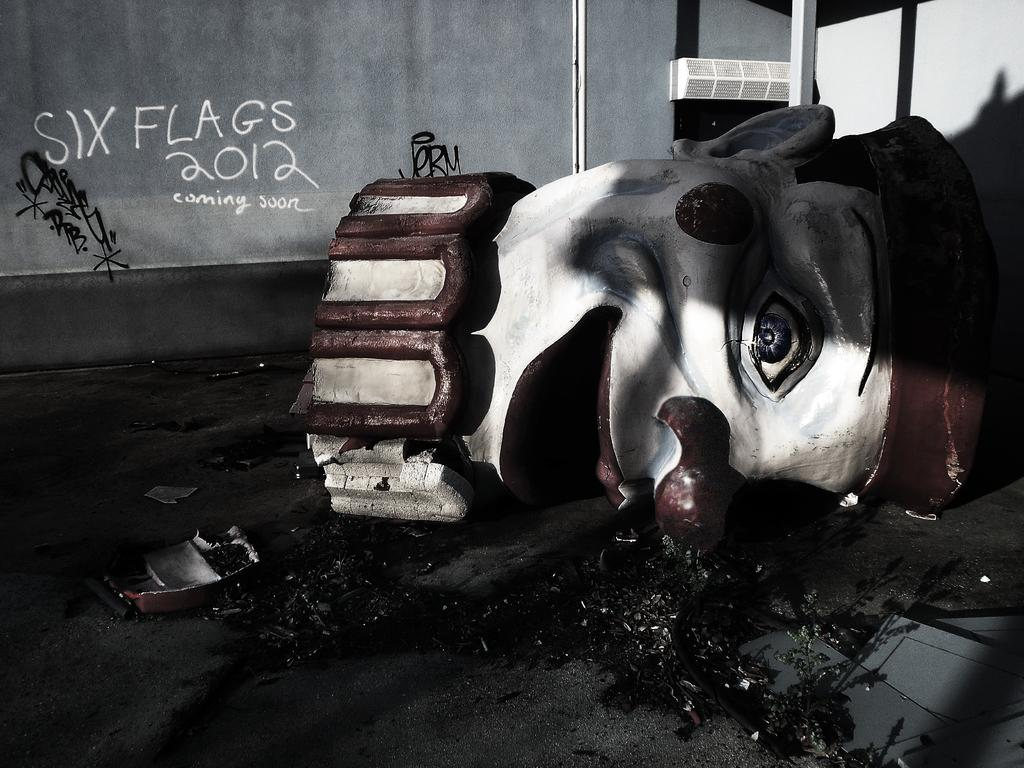What is the main subject in the middle of the image? There is a doll in the middle of the image. What can be seen on the left side of the image? There is text on the left side of the image. What is visible in the background of the image? There is a wall in the background of the image. Can you tell if the image has been altered or edited? Yes, the image appears to be edited. What type of boot is being used for the feast in the image? There is no boot or feast present in the image; it features a doll and text. How many people are skating in the image? There are no people skating in the image; it features a doll and text. 